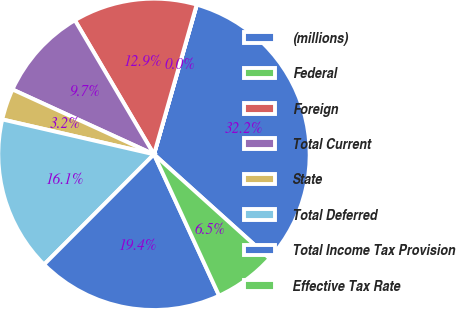Convert chart. <chart><loc_0><loc_0><loc_500><loc_500><pie_chart><fcel>(millions)<fcel>Federal<fcel>Foreign<fcel>Total Current<fcel>State<fcel>Total Deferred<fcel>Total Income Tax Provision<fcel>Effective Tax Rate<nl><fcel>32.23%<fcel>0.02%<fcel>12.9%<fcel>9.68%<fcel>3.24%<fcel>16.12%<fcel>19.35%<fcel>6.46%<nl></chart> 